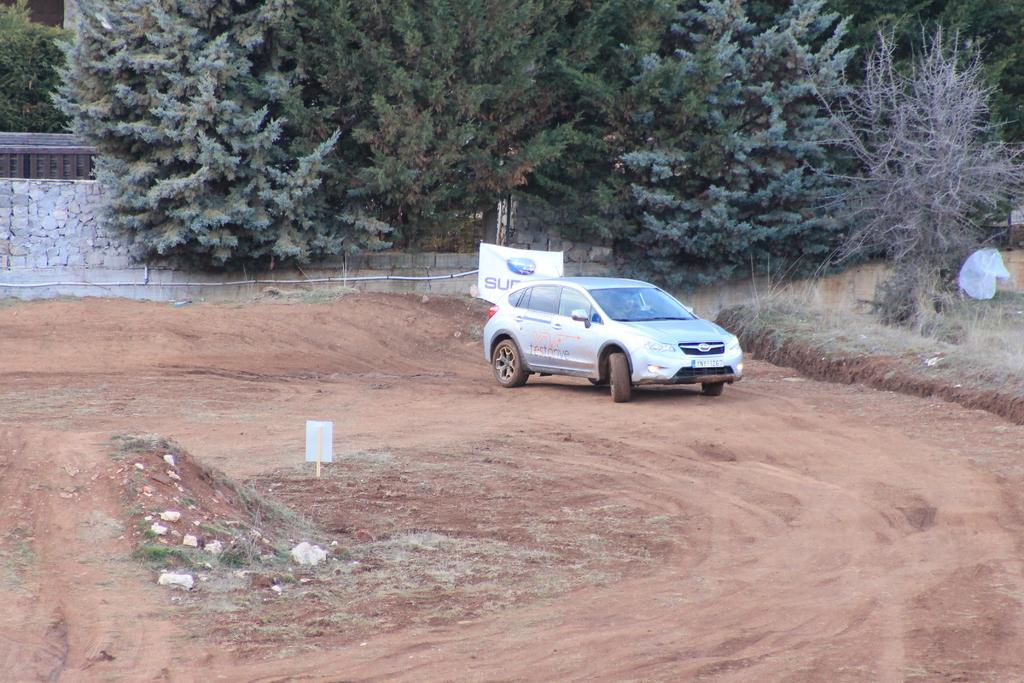What is the main subject of the image? The main subject of the image is a car on a track. What type of surface is the car on? The car is on a track. What other objects can be seen in the image? A flex and metal rods are visible in the image. What type of natural environment is present in the image? There are trees in the image. What type of credit card is being used to work on the hook in the image? There is no credit card, work, or hook present in the image. 